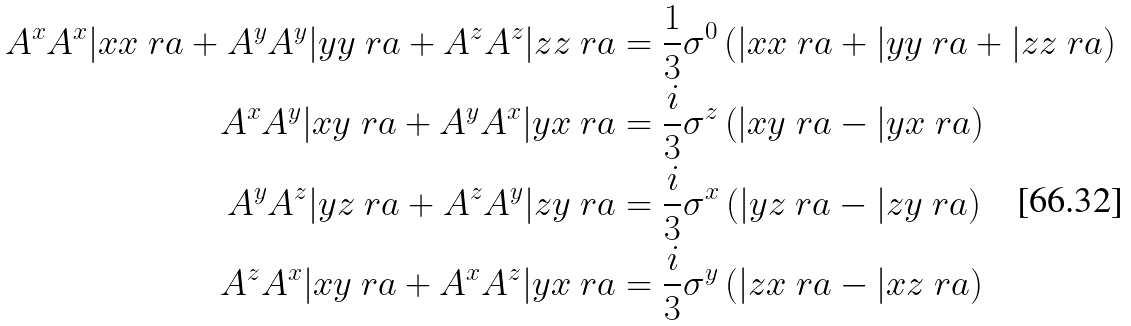<formula> <loc_0><loc_0><loc_500><loc_500>A ^ { x } A ^ { x } | x x \ r a + A ^ { y } A ^ { y } | y y \ r a + A ^ { z } A ^ { z } | z z \ r a & = \frac { 1 } { 3 } \sigma ^ { 0 } \left ( | x x \ r a + | y y \ r a + | z z \ r a \right ) \\ A ^ { x } A ^ { y } | x y \ r a + A ^ { y } A ^ { x } | y x \ r a & = \frac { i } { 3 } \sigma ^ { z } \left ( | x y \ r a - | y x \ r a \right ) \\ A ^ { y } A ^ { z } | y z \ r a + A ^ { z } A ^ { y } | z y \ r a & = \frac { i } { 3 } \sigma ^ { x } \left ( | y z \ r a - | z y \ r a \right ) \\ A ^ { z } A ^ { x } | x y \ r a + A ^ { x } A ^ { z } | y x \ r a & = \frac { i } { 3 } \sigma ^ { y } \left ( | z x \ r a - | x z \ r a \right )</formula> 